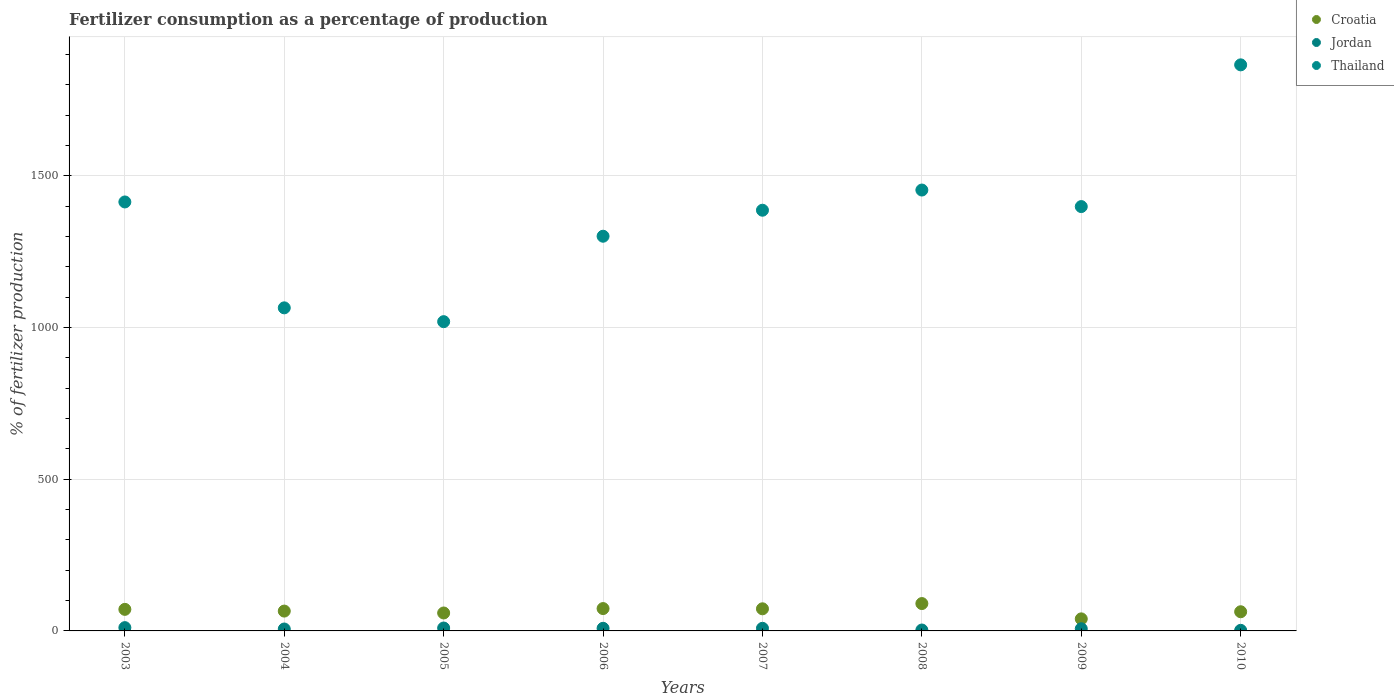Is the number of dotlines equal to the number of legend labels?
Your answer should be compact. Yes. What is the percentage of fertilizers consumed in Thailand in 2009?
Provide a succinct answer. 1398.34. Across all years, what is the maximum percentage of fertilizers consumed in Croatia?
Your answer should be very brief. 90.16. Across all years, what is the minimum percentage of fertilizers consumed in Croatia?
Offer a terse response. 39.71. What is the total percentage of fertilizers consumed in Thailand in the graph?
Offer a very short reply. 1.09e+04. What is the difference between the percentage of fertilizers consumed in Jordan in 2004 and that in 2006?
Your answer should be compact. -2.3. What is the difference between the percentage of fertilizers consumed in Jordan in 2005 and the percentage of fertilizers consumed in Croatia in 2008?
Provide a short and direct response. -80.61. What is the average percentage of fertilizers consumed in Thailand per year?
Provide a succinct answer. 1362.61. In the year 2005, what is the difference between the percentage of fertilizers consumed in Jordan and percentage of fertilizers consumed in Thailand?
Your answer should be very brief. -1009.55. What is the ratio of the percentage of fertilizers consumed in Jordan in 2005 to that in 2008?
Keep it short and to the point. 3.19. What is the difference between the highest and the second highest percentage of fertilizers consumed in Croatia?
Your answer should be very brief. 16.51. What is the difference between the highest and the lowest percentage of fertilizers consumed in Jordan?
Offer a very short reply. 8.87. Is the sum of the percentage of fertilizers consumed in Thailand in 2008 and 2009 greater than the maximum percentage of fertilizers consumed in Croatia across all years?
Your answer should be compact. Yes. Does the percentage of fertilizers consumed in Croatia monotonically increase over the years?
Keep it short and to the point. No. Is the percentage of fertilizers consumed in Croatia strictly less than the percentage of fertilizers consumed in Jordan over the years?
Provide a short and direct response. No. What is the difference between two consecutive major ticks on the Y-axis?
Keep it short and to the point. 500. Are the values on the major ticks of Y-axis written in scientific E-notation?
Keep it short and to the point. No. Does the graph contain any zero values?
Your answer should be very brief. No. Does the graph contain grids?
Give a very brief answer. Yes. Where does the legend appear in the graph?
Keep it short and to the point. Top right. How many legend labels are there?
Your answer should be compact. 3. What is the title of the graph?
Give a very brief answer. Fertilizer consumption as a percentage of production. Does "Ghana" appear as one of the legend labels in the graph?
Your response must be concise. No. What is the label or title of the X-axis?
Your answer should be compact. Years. What is the label or title of the Y-axis?
Provide a succinct answer. % of fertilizer production. What is the % of fertilizer production of Croatia in 2003?
Keep it short and to the point. 71.05. What is the % of fertilizer production in Jordan in 2003?
Ensure brevity in your answer.  10.83. What is the % of fertilizer production of Thailand in 2003?
Make the answer very short. 1413.57. What is the % of fertilizer production of Croatia in 2004?
Offer a terse response. 65.37. What is the % of fertilizer production in Jordan in 2004?
Provide a short and direct response. 6.31. What is the % of fertilizer production in Thailand in 2004?
Provide a succinct answer. 1064.63. What is the % of fertilizer production of Croatia in 2005?
Give a very brief answer. 59.11. What is the % of fertilizer production of Jordan in 2005?
Ensure brevity in your answer.  9.56. What is the % of fertilizer production of Thailand in 2005?
Make the answer very short. 1019.11. What is the % of fertilizer production of Croatia in 2006?
Give a very brief answer. 73.66. What is the % of fertilizer production in Jordan in 2006?
Offer a very short reply. 8.61. What is the % of fertilizer production of Thailand in 2006?
Make the answer very short. 1300.64. What is the % of fertilizer production of Croatia in 2007?
Keep it short and to the point. 72.89. What is the % of fertilizer production of Jordan in 2007?
Offer a terse response. 8.6. What is the % of fertilizer production of Thailand in 2007?
Offer a very short reply. 1386.34. What is the % of fertilizer production in Croatia in 2008?
Offer a terse response. 90.16. What is the % of fertilizer production in Jordan in 2008?
Make the answer very short. 2.99. What is the % of fertilizer production in Thailand in 2008?
Give a very brief answer. 1452.84. What is the % of fertilizer production in Croatia in 2009?
Ensure brevity in your answer.  39.71. What is the % of fertilizer production of Jordan in 2009?
Offer a very short reply. 7.18. What is the % of fertilizer production of Thailand in 2009?
Your answer should be very brief. 1398.34. What is the % of fertilizer production in Croatia in 2010?
Provide a succinct answer. 63.17. What is the % of fertilizer production in Jordan in 2010?
Make the answer very short. 1.96. What is the % of fertilizer production in Thailand in 2010?
Your answer should be very brief. 1865.38. Across all years, what is the maximum % of fertilizer production in Croatia?
Your answer should be very brief. 90.16. Across all years, what is the maximum % of fertilizer production in Jordan?
Provide a short and direct response. 10.83. Across all years, what is the maximum % of fertilizer production in Thailand?
Ensure brevity in your answer.  1865.38. Across all years, what is the minimum % of fertilizer production of Croatia?
Your answer should be very brief. 39.71. Across all years, what is the minimum % of fertilizer production in Jordan?
Your answer should be compact. 1.96. Across all years, what is the minimum % of fertilizer production of Thailand?
Keep it short and to the point. 1019.11. What is the total % of fertilizer production of Croatia in the graph?
Make the answer very short. 535.12. What is the total % of fertilizer production in Jordan in the graph?
Your answer should be compact. 56.04. What is the total % of fertilizer production of Thailand in the graph?
Offer a terse response. 1.09e+04. What is the difference between the % of fertilizer production of Croatia in 2003 and that in 2004?
Offer a very short reply. 5.67. What is the difference between the % of fertilizer production in Jordan in 2003 and that in 2004?
Offer a terse response. 4.52. What is the difference between the % of fertilizer production of Thailand in 2003 and that in 2004?
Provide a succinct answer. 348.95. What is the difference between the % of fertilizer production in Croatia in 2003 and that in 2005?
Keep it short and to the point. 11.94. What is the difference between the % of fertilizer production of Jordan in 2003 and that in 2005?
Give a very brief answer. 1.27. What is the difference between the % of fertilizer production of Thailand in 2003 and that in 2005?
Provide a short and direct response. 394.46. What is the difference between the % of fertilizer production of Croatia in 2003 and that in 2006?
Your answer should be compact. -2.61. What is the difference between the % of fertilizer production in Jordan in 2003 and that in 2006?
Provide a short and direct response. 2.21. What is the difference between the % of fertilizer production in Thailand in 2003 and that in 2006?
Give a very brief answer. 112.93. What is the difference between the % of fertilizer production in Croatia in 2003 and that in 2007?
Your response must be concise. -1.84. What is the difference between the % of fertilizer production in Jordan in 2003 and that in 2007?
Give a very brief answer. 2.22. What is the difference between the % of fertilizer production of Thailand in 2003 and that in 2007?
Provide a succinct answer. 27.24. What is the difference between the % of fertilizer production in Croatia in 2003 and that in 2008?
Your response must be concise. -19.12. What is the difference between the % of fertilizer production of Jordan in 2003 and that in 2008?
Offer a terse response. 7.83. What is the difference between the % of fertilizer production in Thailand in 2003 and that in 2008?
Offer a very short reply. -39.27. What is the difference between the % of fertilizer production of Croatia in 2003 and that in 2009?
Your response must be concise. 31.34. What is the difference between the % of fertilizer production of Jordan in 2003 and that in 2009?
Make the answer very short. 3.65. What is the difference between the % of fertilizer production of Thailand in 2003 and that in 2009?
Provide a short and direct response. 15.24. What is the difference between the % of fertilizer production of Croatia in 2003 and that in 2010?
Provide a short and direct response. 7.88. What is the difference between the % of fertilizer production in Jordan in 2003 and that in 2010?
Ensure brevity in your answer.  8.87. What is the difference between the % of fertilizer production of Thailand in 2003 and that in 2010?
Provide a succinct answer. -451.81. What is the difference between the % of fertilizer production in Croatia in 2004 and that in 2005?
Make the answer very short. 6.26. What is the difference between the % of fertilizer production in Jordan in 2004 and that in 2005?
Keep it short and to the point. -3.25. What is the difference between the % of fertilizer production of Thailand in 2004 and that in 2005?
Your response must be concise. 45.52. What is the difference between the % of fertilizer production in Croatia in 2004 and that in 2006?
Offer a terse response. -8.28. What is the difference between the % of fertilizer production in Jordan in 2004 and that in 2006?
Provide a short and direct response. -2.3. What is the difference between the % of fertilizer production in Thailand in 2004 and that in 2006?
Your response must be concise. -236.01. What is the difference between the % of fertilizer production of Croatia in 2004 and that in 2007?
Offer a terse response. -7.51. What is the difference between the % of fertilizer production in Jordan in 2004 and that in 2007?
Your answer should be compact. -2.29. What is the difference between the % of fertilizer production of Thailand in 2004 and that in 2007?
Offer a very short reply. -321.71. What is the difference between the % of fertilizer production of Croatia in 2004 and that in 2008?
Offer a very short reply. -24.79. What is the difference between the % of fertilizer production in Jordan in 2004 and that in 2008?
Offer a terse response. 3.32. What is the difference between the % of fertilizer production of Thailand in 2004 and that in 2008?
Your answer should be very brief. -388.21. What is the difference between the % of fertilizer production in Croatia in 2004 and that in 2009?
Give a very brief answer. 25.66. What is the difference between the % of fertilizer production of Jordan in 2004 and that in 2009?
Ensure brevity in your answer.  -0.87. What is the difference between the % of fertilizer production of Thailand in 2004 and that in 2009?
Your answer should be very brief. -333.71. What is the difference between the % of fertilizer production of Croatia in 2004 and that in 2010?
Keep it short and to the point. 2.2. What is the difference between the % of fertilizer production of Jordan in 2004 and that in 2010?
Your answer should be very brief. 4.35. What is the difference between the % of fertilizer production in Thailand in 2004 and that in 2010?
Provide a succinct answer. -800.75. What is the difference between the % of fertilizer production in Croatia in 2005 and that in 2006?
Your answer should be compact. -14.55. What is the difference between the % of fertilizer production of Jordan in 2005 and that in 2006?
Make the answer very short. 0.94. What is the difference between the % of fertilizer production in Thailand in 2005 and that in 2006?
Your response must be concise. -281.53. What is the difference between the % of fertilizer production of Croatia in 2005 and that in 2007?
Make the answer very short. -13.78. What is the difference between the % of fertilizer production of Jordan in 2005 and that in 2007?
Provide a succinct answer. 0.95. What is the difference between the % of fertilizer production in Thailand in 2005 and that in 2007?
Offer a very short reply. -367.23. What is the difference between the % of fertilizer production in Croatia in 2005 and that in 2008?
Your answer should be very brief. -31.05. What is the difference between the % of fertilizer production in Jordan in 2005 and that in 2008?
Provide a short and direct response. 6.56. What is the difference between the % of fertilizer production in Thailand in 2005 and that in 2008?
Offer a terse response. -433.73. What is the difference between the % of fertilizer production of Croatia in 2005 and that in 2009?
Keep it short and to the point. 19.4. What is the difference between the % of fertilizer production of Jordan in 2005 and that in 2009?
Provide a short and direct response. 2.38. What is the difference between the % of fertilizer production of Thailand in 2005 and that in 2009?
Keep it short and to the point. -379.23. What is the difference between the % of fertilizer production of Croatia in 2005 and that in 2010?
Make the answer very short. -4.06. What is the difference between the % of fertilizer production in Jordan in 2005 and that in 2010?
Make the answer very short. 7.6. What is the difference between the % of fertilizer production in Thailand in 2005 and that in 2010?
Ensure brevity in your answer.  -846.27. What is the difference between the % of fertilizer production in Croatia in 2006 and that in 2007?
Keep it short and to the point. 0.77. What is the difference between the % of fertilizer production of Jordan in 2006 and that in 2007?
Provide a succinct answer. 0.01. What is the difference between the % of fertilizer production of Thailand in 2006 and that in 2007?
Your answer should be very brief. -85.7. What is the difference between the % of fertilizer production of Croatia in 2006 and that in 2008?
Offer a very short reply. -16.51. What is the difference between the % of fertilizer production of Jordan in 2006 and that in 2008?
Ensure brevity in your answer.  5.62. What is the difference between the % of fertilizer production of Thailand in 2006 and that in 2008?
Your answer should be compact. -152.2. What is the difference between the % of fertilizer production of Croatia in 2006 and that in 2009?
Offer a terse response. 33.95. What is the difference between the % of fertilizer production of Jordan in 2006 and that in 2009?
Offer a terse response. 1.43. What is the difference between the % of fertilizer production of Thailand in 2006 and that in 2009?
Keep it short and to the point. -97.7. What is the difference between the % of fertilizer production in Croatia in 2006 and that in 2010?
Provide a short and direct response. 10.48. What is the difference between the % of fertilizer production of Jordan in 2006 and that in 2010?
Provide a short and direct response. 6.66. What is the difference between the % of fertilizer production in Thailand in 2006 and that in 2010?
Provide a short and direct response. -564.74. What is the difference between the % of fertilizer production in Croatia in 2007 and that in 2008?
Ensure brevity in your answer.  -17.28. What is the difference between the % of fertilizer production of Jordan in 2007 and that in 2008?
Ensure brevity in your answer.  5.61. What is the difference between the % of fertilizer production in Thailand in 2007 and that in 2008?
Provide a succinct answer. -66.5. What is the difference between the % of fertilizer production of Croatia in 2007 and that in 2009?
Your response must be concise. 33.18. What is the difference between the % of fertilizer production in Jordan in 2007 and that in 2009?
Make the answer very short. 1.42. What is the difference between the % of fertilizer production of Thailand in 2007 and that in 2009?
Your answer should be very brief. -12. What is the difference between the % of fertilizer production in Croatia in 2007 and that in 2010?
Offer a very short reply. 9.72. What is the difference between the % of fertilizer production of Jordan in 2007 and that in 2010?
Your response must be concise. 6.65. What is the difference between the % of fertilizer production of Thailand in 2007 and that in 2010?
Give a very brief answer. -479.04. What is the difference between the % of fertilizer production of Croatia in 2008 and that in 2009?
Offer a very short reply. 50.45. What is the difference between the % of fertilizer production in Jordan in 2008 and that in 2009?
Keep it short and to the point. -4.19. What is the difference between the % of fertilizer production of Thailand in 2008 and that in 2009?
Your answer should be compact. 54.51. What is the difference between the % of fertilizer production of Croatia in 2008 and that in 2010?
Keep it short and to the point. 26.99. What is the difference between the % of fertilizer production of Jordan in 2008 and that in 2010?
Give a very brief answer. 1.04. What is the difference between the % of fertilizer production in Thailand in 2008 and that in 2010?
Ensure brevity in your answer.  -412.54. What is the difference between the % of fertilizer production of Croatia in 2009 and that in 2010?
Offer a terse response. -23.46. What is the difference between the % of fertilizer production in Jordan in 2009 and that in 2010?
Provide a succinct answer. 5.22. What is the difference between the % of fertilizer production of Thailand in 2009 and that in 2010?
Offer a terse response. -467.05. What is the difference between the % of fertilizer production in Croatia in 2003 and the % of fertilizer production in Jordan in 2004?
Your answer should be compact. 64.74. What is the difference between the % of fertilizer production in Croatia in 2003 and the % of fertilizer production in Thailand in 2004?
Provide a short and direct response. -993.58. What is the difference between the % of fertilizer production in Jordan in 2003 and the % of fertilizer production in Thailand in 2004?
Provide a succinct answer. -1053.8. What is the difference between the % of fertilizer production of Croatia in 2003 and the % of fertilizer production of Jordan in 2005?
Your answer should be very brief. 61.49. What is the difference between the % of fertilizer production in Croatia in 2003 and the % of fertilizer production in Thailand in 2005?
Your answer should be very brief. -948.06. What is the difference between the % of fertilizer production of Jordan in 2003 and the % of fertilizer production of Thailand in 2005?
Provide a succinct answer. -1008.28. What is the difference between the % of fertilizer production in Croatia in 2003 and the % of fertilizer production in Jordan in 2006?
Offer a very short reply. 62.43. What is the difference between the % of fertilizer production of Croatia in 2003 and the % of fertilizer production of Thailand in 2006?
Your response must be concise. -1229.59. What is the difference between the % of fertilizer production of Jordan in 2003 and the % of fertilizer production of Thailand in 2006?
Make the answer very short. -1289.81. What is the difference between the % of fertilizer production of Croatia in 2003 and the % of fertilizer production of Jordan in 2007?
Your response must be concise. 62.44. What is the difference between the % of fertilizer production of Croatia in 2003 and the % of fertilizer production of Thailand in 2007?
Your answer should be compact. -1315.29. What is the difference between the % of fertilizer production in Jordan in 2003 and the % of fertilizer production in Thailand in 2007?
Your answer should be compact. -1375.51. What is the difference between the % of fertilizer production in Croatia in 2003 and the % of fertilizer production in Jordan in 2008?
Your answer should be compact. 68.05. What is the difference between the % of fertilizer production of Croatia in 2003 and the % of fertilizer production of Thailand in 2008?
Offer a very short reply. -1381.79. What is the difference between the % of fertilizer production in Jordan in 2003 and the % of fertilizer production in Thailand in 2008?
Provide a succinct answer. -1442.02. What is the difference between the % of fertilizer production in Croatia in 2003 and the % of fertilizer production in Jordan in 2009?
Offer a terse response. 63.87. What is the difference between the % of fertilizer production in Croatia in 2003 and the % of fertilizer production in Thailand in 2009?
Offer a very short reply. -1327.29. What is the difference between the % of fertilizer production of Jordan in 2003 and the % of fertilizer production of Thailand in 2009?
Make the answer very short. -1387.51. What is the difference between the % of fertilizer production in Croatia in 2003 and the % of fertilizer production in Jordan in 2010?
Your answer should be very brief. 69.09. What is the difference between the % of fertilizer production of Croatia in 2003 and the % of fertilizer production of Thailand in 2010?
Offer a terse response. -1794.34. What is the difference between the % of fertilizer production in Jordan in 2003 and the % of fertilizer production in Thailand in 2010?
Offer a terse response. -1854.56. What is the difference between the % of fertilizer production of Croatia in 2004 and the % of fertilizer production of Jordan in 2005?
Your answer should be very brief. 55.82. What is the difference between the % of fertilizer production of Croatia in 2004 and the % of fertilizer production of Thailand in 2005?
Your answer should be very brief. -953.74. What is the difference between the % of fertilizer production of Jordan in 2004 and the % of fertilizer production of Thailand in 2005?
Give a very brief answer. -1012.8. What is the difference between the % of fertilizer production of Croatia in 2004 and the % of fertilizer production of Jordan in 2006?
Your answer should be compact. 56.76. What is the difference between the % of fertilizer production of Croatia in 2004 and the % of fertilizer production of Thailand in 2006?
Provide a succinct answer. -1235.27. What is the difference between the % of fertilizer production in Jordan in 2004 and the % of fertilizer production in Thailand in 2006?
Your response must be concise. -1294.33. What is the difference between the % of fertilizer production in Croatia in 2004 and the % of fertilizer production in Jordan in 2007?
Your response must be concise. 56.77. What is the difference between the % of fertilizer production of Croatia in 2004 and the % of fertilizer production of Thailand in 2007?
Offer a terse response. -1320.96. What is the difference between the % of fertilizer production of Jordan in 2004 and the % of fertilizer production of Thailand in 2007?
Your answer should be very brief. -1380.03. What is the difference between the % of fertilizer production of Croatia in 2004 and the % of fertilizer production of Jordan in 2008?
Give a very brief answer. 62.38. What is the difference between the % of fertilizer production in Croatia in 2004 and the % of fertilizer production in Thailand in 2008?
Ensure brevity in your answer.  -1387.47. What is the difference between the % of fertilizer production of Jordan in 2004 and the % of fertilizer production of Thailand in 2008?
Provide a succinct answer. -1446.53. What is the difference between the % of fertilizer production in Croatia in 2004 and the % of fertilizer production in Jordan in 2009?
Offer a terse response. 58.2. What is the difference between the % of fertilizer production in Croatia in 2004 and the % of fertilizer production in Thailand in 2009?
Ensure brevity in your answer.  -1332.96. What is the difference between the % of fertilizer production in Jordan in 2004 and the % of fertilizer production in Thailand in 2009?
Give a very brief answer. -1392.03. What is the difference between the % of fertilizer production in Croatia in 2004 and the % of fertilizer production in Jordan in 2010?
Provide a short and direct response. 63.42. What is the difference between the % of fertilizer production of Croatia in 2004 and the % of fertilizer production of Thailand in 2010?
Your response must be concise. -1800.01. What is the difference between the % of fertilizer production in Jordan in 2004 and the % of fertilizer production in Thailand in 2010?
Ensure brevity in your answer.  -1859.07. What is the difference between the % of fertilizer production of Croatia in 2005 and the % of fertilizer production of Jordan in 2006?
Give a very brief answer. 50.5. What is the difference between the % of fertilizer production of Croatia in 2005 and the % of fertilizer production of Thailand in 2006?
Make the answer very short. -1241.53. What is the difference between the % of fertilizer production in Jordan in 2005 and the % of fertilizer production in Thailand in 2006?
Make the answer very short. -1291.08. What is the difference between the % of fertilizer production of Croatia in 2005 and the % of fertilizer production of Jordan in 2007?
Provide a succinct answer. 50.51. What is the difference between the % of fertilizer production in Croatia in 2005 and the % of fertilizer production in Thailand in 2007?
Your answer should be compact. -1327.23. What is the difference between the % of fertilizer production in Jordan in 2005 and the % of fertilizer production in Thailand in 2007?
Your answer should be very brief. -1376.78. What is the difference between the % of fertilizer production of Croatia in 2005 and the % of fertilizer production of Jordan in 2008?
Your answer should be very brief. 56.12. What is the difference between the % of fertilizer production of Croatia in 2005 and the % of fertilizer production of Thailand in 2008?
Provide a succinct answer. -1393.73. What is the difference between the % of fertilizer production in Jordan in 2005 and the % of fertilizer production in Thailand in 2008?
Make the answer very short. -1443.29. What is the difference between the % of fertilizer production in Croatia in 2005 and the % of fertilizer production in Jordan in 2009?
Make the answer very short. 51.93. What is the difference between the % of fertilizer production in Croatia in 2005 and the % of fertilizer production in Thailand in 2009?
Make the answer very short. -1339.23. What is the difference between the % of fertilizer production of Jordan in 2005 and the % of fertilizer production of Thailand in 2009?
Give a very brief answer. -1388.78. What is the difference between the % of fertilizer production in Croatia in 2005 and the % of fertilizer production in Jordan in 2010?
Provide a succinct answer. 57.15. What is the difference between the % of fertilizer production of Croatia in 2005 and the % of fertilizer production of Thailand in 2010?
Your answer should be very brief. -1806.27. What is the difference between the % of fertilizer production in Jordan in 2005 and the % of fertilizer production in Thailand in 2010?
Provide a short and direct response. -1855.83. What is the difference between the % of fertilizer production of Croatia in 2006 and the % of fertilizer production of Jordan in 2007?
Provide a short and direct response. 65.05. What is the difference between the % of fertilizer production of Croatia in 2006 and the % of fertilizer production of Thailand in 2007?
Provide a succinct answer. -1312.68. What is the difference between the % of fertilizer production of Jordan in 2006 and the % of fertilizer production of Thailand in 2007?
Give a very brief answer. -1377.73. What is the difference between the % of fertilizer production of Croatia in 2006 and the % of fertilizer production of Jordan in 2008?
Offer a terse response. 70.66. What is the difference between the % of fertilizer production in Croatia in 2006 and the % of fertilizer production in Thailand in 2008?
Provide a short and direct response. -1379.19. What is the difference between the % of fertilizer production in Jordan in 2006 and the % of fertilizer production in Thailand in 2008?
Offer a terse response. -1444.23. What is the difference between the % of fertilizer production in Croatia in 2006 and the % of fertilizer production in Jordan in 2009?
Your response must be concise. 66.48. What is the difference between the % of fertilizer production of Croatia in 2006 and the % of fertilizer production of Thailand in 2009?
Make the answer very short. -1324.68. What is the difference between the % of fertilizer production in Jordan in 2006 and the % of fertilizer production in Thailand in 2009?
Give a very brief answer. -1389.72. What is the difference between the % of fertilizer production in Croatia in 2006 and the % of fertilizer production in Jordan in 2010?
Provide a short and direct response. 71.7. What is the difference between the % of fertilizer production in Croatia in 2006 and the % of fertilizer production in Thailand in 2010?
Ensure brevity in your answer.  -1791.73. What is the difference between the % of fertilizer production in Jordan in 2006 and the % of fertilizer production in Thailand in 2010?
Keep it short and to the point. -1856.77. What is the difference between the % of fertilizer production of Croatia in 2007 and the % of fertilizer production of Jordan in 2008?
Make the answer very short. 69.89. What is the difference between the % of fertilizer production of Croatia in 2007 and the % of fertilizer production of Thailand in 2008?
Provide a succinct answer. -1379.95. What is the difference between the % of fertilizer production of Jordan in 2007 and the % of fertilizer production of Thailand in 2008?
Your answer should be very brief. -1444.24. What is the difference between the % of fertilizer production of Croatia in 2007 and the % of fertilizer production of Jordan in 2009?
Your answer should be compact. 65.71. What is the difference between the % of fertilizer production in Croatia in 2007 and the % of fertilizer production in Thailand in 2009?
Offer a very short reply. -1325.45. What is the difference between the % of fertilizer production of Jordan in 2007 and the % of fertilizer production of Thailand in 2009?
Provide a short and direct response. -1389.73. What is the difference between the % of fertilizer production of Croatia in 2007 and the % of fertilizer production of Jordan in 2010?
Provide a succinct answer. 70.93. What is the difference between the % of fertilizer production of Croatia in 2007 and the % of fertilizer production of Thailand in 2010?
Ensure brevity in your answer.  -1792.49. What is the difference between the % of fertilizer production in Jordan in 2007 and the % of fertilizer production in Thailand in 2010?
Ensure brevity in your answer.  -1856.78. What is the difference between the % of fertilizer production in Croatia in 2008 and the % of fertilizer production in Jordan in 2009?
Offer a terse response. 82.98. What is the difference between the % of fertilizer production in Croatia in 2008 and the % of fertilizer production in Thailand in 2009?
Ensure brevity in your answer.  -1308.17. What is the difference between the % of fertilizer production of Jordan in 2008 and the % of fertilizer production of Thailand in 2009?
Your answer should be very brief. -1395.34. What is the difference between the % of fertilizer production in Croatia in 2008 and the % of fertilizer production in Jordan in 2010?
Keep it short and to the point. 88.21. What is the difference between the % of fertilizer production of Croatia in 2008 and the % of fertilizer production of Thailand in 2010?
Your answer should be compact. -1775.22. What is the difference between the % of fertilizer production in Jordan in 2008 and the % of fertilizer production in Thailand in 2010?
Ensure brevity in your answer.  -1862.39. What is the difference between the % of fertilizer production of Croatia in 2009 and the % of fertilizer production of Jordan in 2010?
Provide a short and direct response. 37.75. What is the difference between the % of fertilizer production in Croatia in 2009 and the % of fertilizer production in Thailand in 2010?
Offer a very short reply. -1825.67. What is the difference between the % of fertilizer production of Jordan in 2009 and the % of fertilizer production of Thailand in 2010?
Your answer should be very brief. -1858.2. What is the average % of fertilizer production in Croatia per year?
Your answer should be very brief. 66.89. What is the average % of fertilizer production in Jordan per year?
Your answer should be compact. 7. What is the average % of fertilizer production in Thailand per year?
Offer a very short reply. 1362.61. In the year 2003, what is the difference between the % of fertilizer production in Croatia and % of fertilizer production in Jordan?
Keep it short and to the point. 60.22. In the year 2003, what is the difference between the % of fertilizer production in Croatia and % of fertilizer production in Thailand?
Offer a terse response. -1342.53. In the year 2003, what is the difference between the % of fertilizer production of Jordan and % of fertilizer production of Thailand?
Make the answer very short. -1402.75. In the year 2004, what is the difference between the % of fertilizer production in Croatia and % of fertilizer production in Jordan?
Offer a terse response. 59.06. In the year 2004, what is the difference between the % of fertilizer production in Croatia and % of fertilizer production in Thailand?
Offer a terse response. -999.25. In the year 2004, what is the difference between the % of fertilizer production in Jordan and % of fertilizer production in Thailand?
Your response must be concise. -1058.32. In the year 2005, what is the difference between the % of fertilizer production in Croatia and % of fertilizer production in Jordan?
Your response must be concise. 49.55. In the year 2005, what is the difference between the % of fertilizer production of Croatia and % of fertilizer production of Thailand?
Your answer should be compact. -960. In the year 2005, what is the difference between the % of fertilizer production in Jordan and % of fertilizer production in Thailand?
Provide a short and direct response. -1009.55. In the year 2006, what is the difference between the % of fertilizer production of Croatia and % of fertilizer production of Jordan?
Make the answer very short. 65.04. In the year 2006, what is the difference between the % of fertilizer production in Croatia and % of fertilizer production in Thailand?
Keep it short and to the point. -1226.98. In the year 2006, what is the difference between the % of fertilizer production of Jordan and % of fertilizer production of Thailand?
Offer a terse response. -1292.03. In the year 2007, what is the difference between the % of fertilizer production in Croatia and % of fertilizer production in Jordan?
Offer a very short reply. 64.29. In the year 2007, what is the difference between the % of fertilizer production in Croatia and % of fertilizer production in Thailand?
Your answer should be very brief. -1313.45. In the year 2007, what is the difference between the % of fertilizer production in Jordan and % of fertilizer production in Thailand?
Give a very brief answer. -1377.74. In the year 2008, what is the difference between the % of fertilizer production of Croatia and % of fertilizer production of Jordan?
Your answer should be compact. 87.17. In the year 2008, what is the difference between the % of fertilizer production of Croatia and % of fertilizer production of Thailand?
Provide a short and direct response. -1362.68. In the year 2008, what is the difference between the % of fertilizer production in Jordan and % of fertilizer production in Thailand?
Offer a very short reply. -1449.85. In the year 2009, what is the difference between the % of fertilizer production of Croatia and % of fertilizer production of Jordan?
Offer a terse response. 32.53. In the year 2009, what is the difference between the % of fertilizer production of Croatia and % of fertilizer production of Thailand?
Keep it short and to the point. -1358.63. In the year 2009, what is the difference between the % of fertilizer production in Jordan and % of fertilizer production in Thailand?
Provide a succinct answer. -1391.16. In the year 2010, what is the difference between the % of fertilizer production in Croatia and % of fertilizer production in Jordan?
Make the answer very short. 61.22. In the year 2010, what is the difference between the % of fertilizer production of Croatia and % of fertilizer production of Thailand?
Offer a very short reply. -1802.21. In the year 2010, what is the difference between the % of fertilizer production in Jordan and % of fertilizer production in Thailand?
Offer a terse response. -1863.42. What is the ratio of the % of fertilizer production in Croatia in 2003 to that in 2004?
Provide a succinct answer. 1.09. What is the ratio of the % of fertilizer production of Jordan in 2003 to that in 2004?
Keep it short and to the point. 1.72. What is the ratio of the % of fertilizer production of Thailand in 2003 to that in 2004?
Offer a terse response. 1.33. What is the ratio of the % of fertilizer production of Croatia in 2003 to that in 2005?
Your response must be concise. 1.2. What is the ratio of the % of fertilizer production in Jordan in 2003 to that in 2005?
Give a very brief answer. 1.13. What is the ratio of the % of fertilizer production of Thailand in 2003 to that in 2005?
Ensure brevity in your answer.  1.39. What is the ratio of the % of fertilizer production of Croatia in 2003 to that in 2006?
Provide a short and direct response. 0.96. What is the ratio of the % of fertilizer production of Jordan in 2003 to that in 2006?
Keep it short and to the point. 1.26. What is the ratio of the % of fertilizer production in Thailand in 2003 to that in 2006?
Provide a short and direct response. 1.09. What is the ratio of the % of fertilizer production in Croatia in 2003 to that in 2007?
Provide a succinct answer. 0.97. What is the ratio of the % of fertilizer production in Jordan in 2003 to that in 2007?
Ensure brevity in your answer.  1.26. What is the ratio of the % of fertilizer production of Thailand in 2003 to that in 2007?
Ensure brevity in your answer.  1.02. What is the ratio of the % of fertilizer production in Croatia in 2003 to that in 2008?
Your response must be concise. 0.79. What is the ratio of the % of fertilizer production of Jordan in 2003 to that in 2008?
Give a very brief answer. 3.62. What is the ratio of the % of fertilizer production in Thailand in 2003 to that in 2008?
Your answer should be compact. 0.97. What is the ratio of the % of fertilizer production of Croatia in 2003 to that in 2009?
Make the answer very short. 1.79. What is the ratio of the % of fertilizer production in Jordan in 2003 to that in 2009?
Your answer should be compact. 1.51. What is the ratio of the % of fertilizer production in Thailand in 2003 to that in 2009?
Make the answer very short. 1.01. What is the ratio of the % of fertilizer production in Croatia in 2003 to that in 2010?
Ensure brevity in your answer.  1.12. What is the ratio of the % of fertilizer production of Jordan in 2003 to that in 2010?
Keep it short and to the point. 5.53. What is the ratio of the % of fertilizer production of Thailand in 2003 to that in 2010?
Ensure brevity in your answer.  0.76. What is the ratio of the % of fertilizer production of Croatia in 2004 to that in 2005?
Offer a terse response. 1.11. What is the ratio of the % of fertilizer production of Jordan in 2004 to that in 2005?
Provide a short and direct response. 0.66. What is the ratio of the % of fertilizer production of Thailand in 2004 to that in 2005?
Provide a short and direct response. 1.04. What is the ratio of the % of fertilizer production of Croatia in 2004 to that in 2006?
Keep it short and to the point. 0.89. What is the ratio of the % of fertilizer production of Jordan in 2004 to that in 2006?
Provide a short and direct response. 0.73. What is the ratio of the % of fertilizer production of Thailand in 2004 to that in 2006?
Give a very brief answer. 0.82. What is the ratio of the % of fertilizer production of Croatia in 2004 to that in 2007?
Your answer should be compact. 0.9. What is the ratio of the % of fertilizer production of Jordan in 2004 to that in 2007?
Provide a short and direct response. 0.73. What is the ratio of the % of fertilizer production in Thailand in 2004 to that in 2007?
Make the answer very short. 0.77. What is the ratio of the % of fertilizer production of Croatia in 2004 to that in 2008?
Offer a very short reply. 0.73. What is the ratio of the % of fertilizer production of Jordan in 2004 to that in 2008?
Ensure brevity in your answer.  2.11. What is the ratio of the % of fertilizer production in Thailand in 2004 to that in 2008?
Keep it short and to the point. 0.73. What is the ratio of the % of fertilizer production in Croatia in 2004 to that in 2009?
Ensure brevity in your answer.  1.65. What is the ratio of the % of fertilizer production of Jordan in 2004 to that in 2009?
Offer a very short reply. 0.88. What is the ratio of the % of fertilizer production of Thailand in 2004 to that in 2009?
Ensure brevity in your answer.  0.76. What is the ratio of the % of fertilizer production of Croatia in 2004 to that in 2010?
Give a very brief answer. 1.03. What is the ratio of the % of fertilizer production in Jordan in 2004 to that in 2010?
Give a very brief answer. 3.22. What is the ratio of the % of fertilizer production in Thailand in 2004 to that in 2010?
Give a very brief answer. 0.57. What is the ratio of the % of fertilizer production in Croatia in 2005 to that in 2006?
Offer a terse response. 0.8. What is the ratio of the % of fertilizer production in Jordan in 2005 to that in 2006?
Ensure brevity in your answer.  1.11. What is the ratio of the % of fertilizer production in Thailand in 2005 to that in 2006?
Keep it short and to the point. 0.78. What is the ratio of the % of fertilizer production in Croatia in 2005 to that in 2007?
Your answer should be very brief. 0.81. What is the ratio of the % of fertilizer production in Jordan in 2005 to that in 2007?
Your answer should be very brief. 1.11. What is the ratio of the % of fertilizer production of Thailand in 2005 to that in 2007?
Offer a very short reply. 0.74. What is the ratio of the % of fertilizer production of Croatia in 2005 to that in 2008?
Offer a very short reply. 0.66. What is the ratio of the % of fertilizer production of Jordan in 2005 to that in 2008?
Give a very brief answer. 3.19. What is the ratio of the % of fertilizer production of Thailand in 2005 to that in 2008?
Your answer should be compact. 0.7. What is the ratio of the % of fertilizer production of Croatia in 2005 to that in 2009?
Your answer should be compact. 1.49. What is the ratio of the % of fertilizer production of Jordan in 2005 to that in 2009?
Make the answer very short. 1.33. What is the ratio of the % of fertilizer production of Thailand in 2005 to that in 2009?
Offer a terse response. 0.73. What is the ratio of the % of fertilizer production in Croatia in 2005 to that in 2010?
Ensure brevity in your answer.  0.94. What is the ratio of the % of fertilizer production of Jordan in 2005 to that in 2010?
Ensure brevity in your answer.  4.88. What is the ratio of the % of fertilizer production in Thailand in 2005 to that in 2010?
Offer a terse response. 0.55. What is the ratio of the % of fertilizer production in Croatia in 2006 to that in 2007?
Make the answer very short. 1.01. What is the ratio of the % of fertilizer production of Jordan in 2006 to that in 2007?
Provide a succinct answer. 1. What is the ratio of the % of fertilizer production in Thailand in 2006 to that in 2007?
Your response must be concise. 0.94. What is the ratio of the % of fertilizer production in Croatia in 2006 to that in 2008?
Offer a terse response. 0.82. What is the ratio of the % of fertilizer production in Jordan in 2006 to that in 2008?
Offer a terse response. 2.88. What is the ratio of the % of fertilizer production in Thailand in 2006 to that in 2008?
Your answer should be compact. 0.9. What is the ratio of the % of fertilizer production in Croatia in 2006 to that in 2009?
Give a very brief answer. 1.85. What is the ratio of the % of fertilizer production in Jordan in 2006 to that in 2009?
Keep it short and to the point. 1.2. What is the ratio of the % of fertilizer production of Thailand in 2006 to that in 2009?
Ensure brevity in your answer.  0.93. What is the ratio of the % of fertilizer production in Croatia in 2006 to that in 2010?
Make the answer very short. 1.17. What is the ratio of the % of fertilizer production of Jordan in 2006 to that in 2010?
Offer a terse response. 4.4. What is the ratio of the % of fertilizer production of Thailand in 2006 to that in 2010?
Offer a terse response. 0.7. What is the ratio of the % of fertilizer production in Croatia in 2007 to that in 2008?
Offer a very short reply. 0.81. What is the ratio of the % of fertilizer production of Jordan in 2007 to that in 2008?
Keep it short and to the point. 2.87. What is the ratio of the % of fertilizer production of Thailand in 2007 to that in 2008?
Offer a very short reply. 0.95. What is the ratio of the % of fertilizer production of Croatia in 2007 to that in 2009?
Your answer should be very brief. 1.84. What is the ratio of the % of fertilizer production of Jordan in 2007 to that in 2009?
Your answer should be compact. 1.2. What is the ratio of the % of fertilizer production in Croatia in 2007 to that in 2010?
Offer a terse response. 1.15. What is the ratio of the % of fertilizer production of Jordan in 2007 to that in 2010?
Your response must be concise. 4.39. What is the ratio of the % of fertilizer production of Thailand in 2007 to that in 2010?
Ensure brevity in your answer.  0.74. What is the ratio of the % of fertilizer production in Croatia in 2008 to that in 2009?
Keep it short and to the point. 2.27. What is the ratio of the % of fertilizer production in Jordan in 2008 to that in 2009?
Ensure brevity in your answer.  0.42. What is the ratio of the % of fertilizer production of Thailand in 2008 to that in 2009?
Offer a very short reply. 1.04. What is the ratio of the % of fertilizer production of Croatia in 2008 to that in 2010?
Make the answer very short. 1.43. What is the ratio of the % of fertilizer production of Jordan in 2008 to that in 2010?
Your answer should be compact. 1.53. What is the ratio of the % of fertilizer production in Thailand in 2008 to that in 2010?
Ensure brevity in your answer.  0.78. What is the ratio of the % of fertilizer production of Croatia in 2009 to that in 2010?
Keep it short and to the point. 0.63. What is the ratio of the % of fertilizer production in Jordan in 2009 to that in 2010?
Offer a very short reply. 3.67. What is the ratio of the % of fertilizer production in Thailand in 2009 to that in 2010?
Offer a terse response. 0.75. What is the difference between the highest and the second highest % of fertilizer production in Croatia?
Your response must be concise. 16.51. What is the difference between the highest and the second highest % of fertilizer production of Jordan?
Give a very brief answer. 1.27. What is the difference between the highest and the second highest % of fertilizer production of Thailand?
Keep it short and to the point. 412.54. What is the difference between the highest and the lowest % of fertilizer production of Croatia?
Ensure brevity in your answer.  50.45. What is the difference between the highest and the lowest % of fertilizer production of Jordan?
Provide a short and direct response. 8.87. What is the difference between the highest and the lowest % of fertilizer production in Thailand?
Your answer should be very brief. 846.27. 